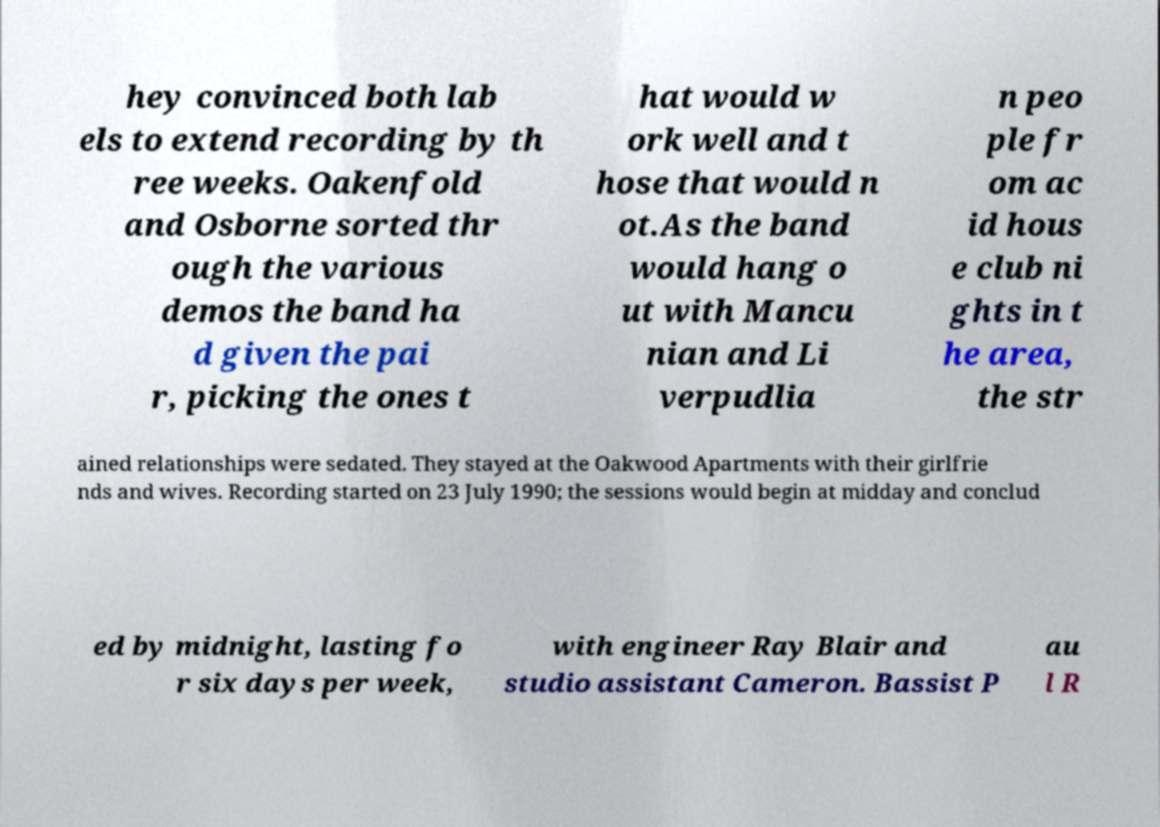I need the written content from this picture converted into text. Can you do that? hey convinced both lab els to extend recording by th ree weeks. Oakenfold and Osborne sorted thr ough the various demos the band ha d given the pai r, picking the ones t hat would w ork well and t hose that would n ot.As the band would hang o ut with Mancu nian and Li verpudlia n peo ple fr om ac id hous e club ni ghts in t he area, the str ained relationships were sedated. They stayed at the Oakwood Apartments with their girlfrie nds and wives. Recording started on 23 July 1990; the sessions would begin at midday and conclud ed by midnight, lasting fo r six days per week, with engineer Ray Blair and studio assistant Cameron. Bassist P au l R 